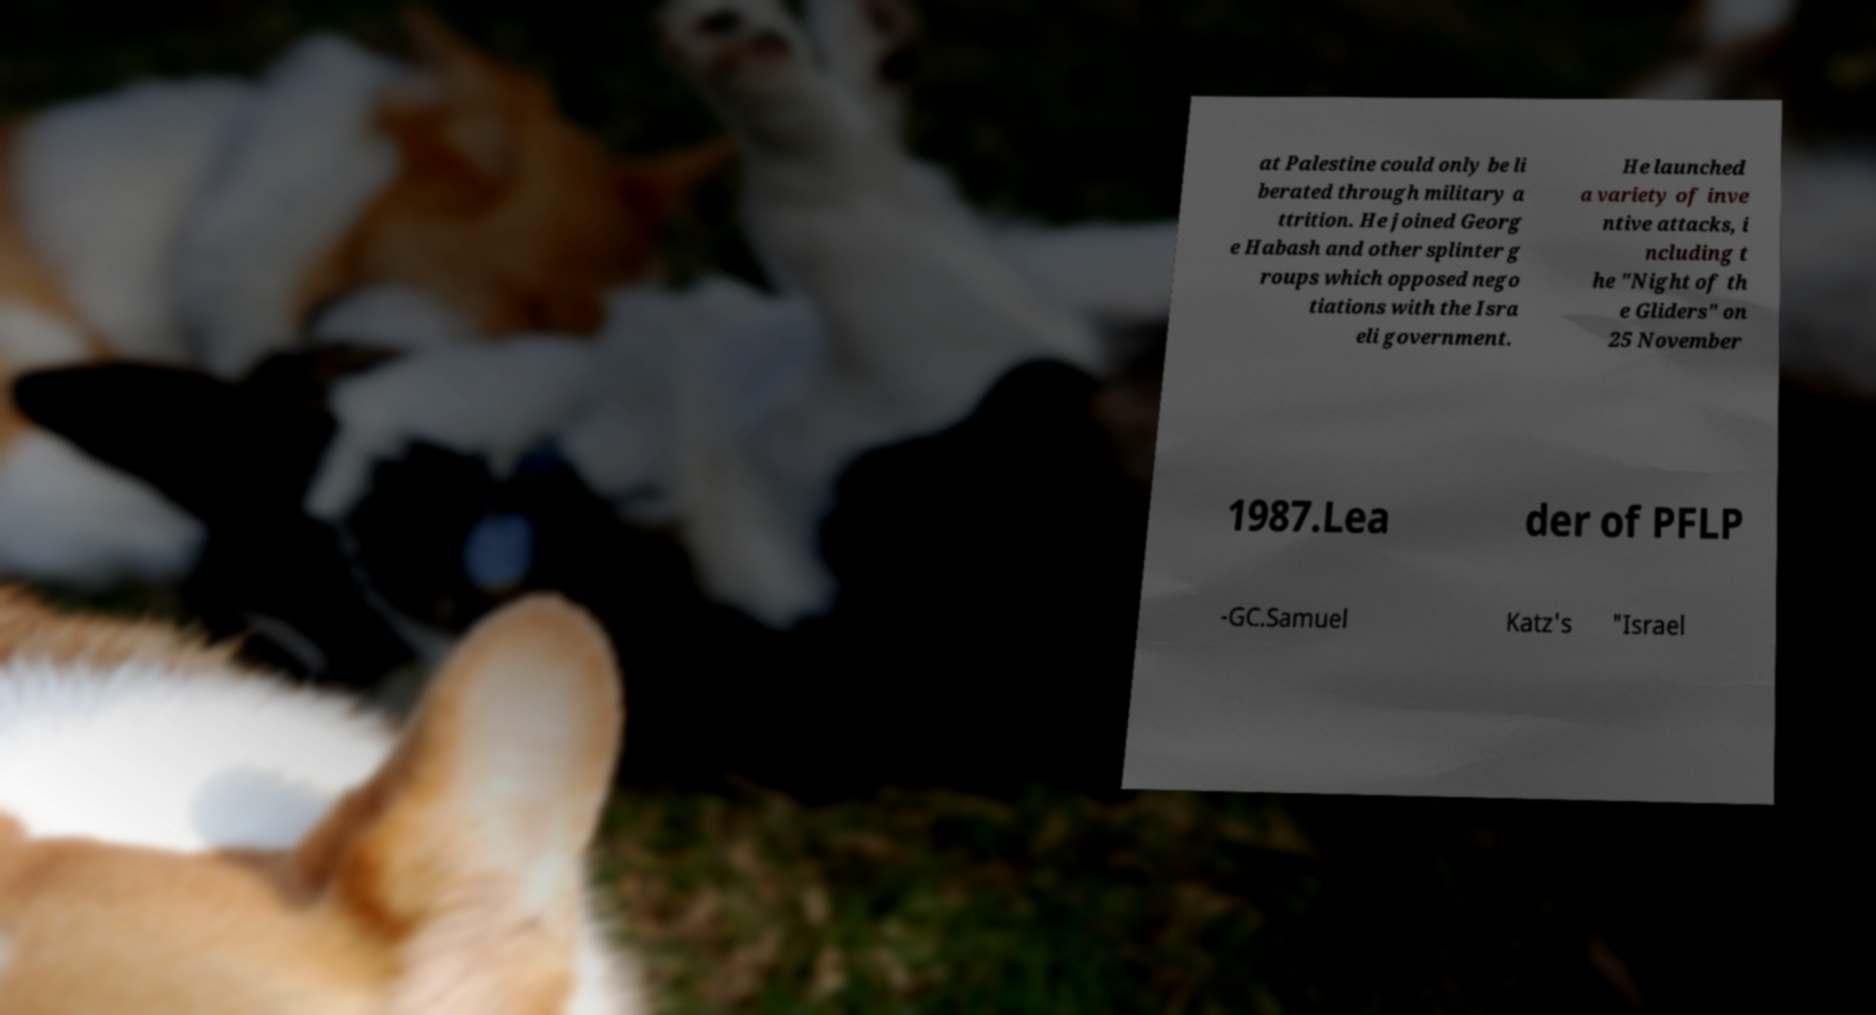For documentation purposes, I need the text within this image transcribed. Could you provide that? at Palestine could only be li berated through military a ttrition. He joined Georg e Habash and other splinter g roups which opposed nego tiations with the Isra eli government. He launched a variety of inve ntive attacks, i ncluding t he "Night of th e Gliders" on 25 November 1987.Lea der of PFLP -GC.Samuel Katz's "Israel 